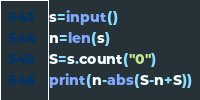<code> <loc_0><loc_0><loc_500><loc_500><_Python_>s=input()
n=len(s)
S=s.count("0")
print(n-abs(S-n+S))</code> 